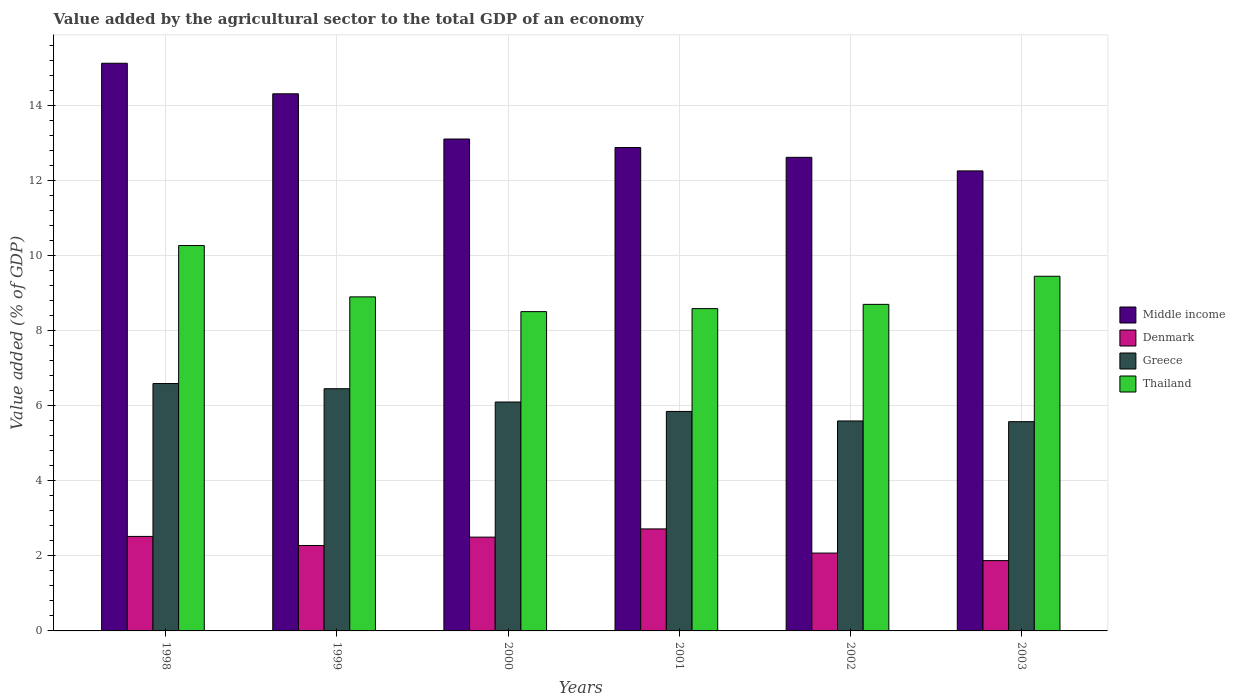How many different coloured bars are there?
Make the answer very short. 4. How many groups of bars are there?
Your answer should be very brief. 6. Are the number of bars per tick equal to the number of legend labels?
Ensure brevity in your answer.  Yes. Are the number of bars on each tick of the X-axis equal?
Offer a terse response. Yes. What is the label of the 4th group of bars from the left?
Give a very brief answer. 2001. In how many cases, is the number of bars for a given year not equal to the number of legend labels?
Provide a succinct answer. 0. What is the value added by the agricultural sector to the total GDP in Middle income in 2003?
Provide a succinct answer. 12.25. Across all years, what is the maximum value added by the agricultural sector to the total GDP in Thailand?
Ensure brevity in your answer.  10.26. Across all years, what is the minimum value added by the agricultural sector to the total GDP in Greece?
Provide a short and direct response. 5.57. What is the total value added by the agricultural sector to the total GDP in Middle income in the graph?
Your answer should be very brief. 80.26. What is the difference between the value added by the agricultural sector to the total GDP in Thailand in 1998 and that in 2002?
Keep it short and to the point. 1.57. What is the difference between the value added by the agricultural sector to the total GDP in Greece in 2000 and the value added by the agricultural sector to the total GDP in Denmark in 1998?
Give a very brief answer. 3.58. What is the average value added by the agricultural sector to the total GDP in Thailand per year?
Ensure brevity in your answer.  9.06. In the year 1998, what is the difference between the value added by the agricultural sector to the total GDP in Denmark and value added by the agricultural sector to the total GDP in Thailand?
Provide a short and direct response. -7.75. What is the ratio of the value added by the agricultural sector to the total GDP in Greece in 1998 to that in 2000?
Offer a very short reply. 1.08. Is the difference between the value added by the agricultural sector to the total GDP in Denmark in 1999 and 2000 greater than the difference between the value added by the agricultural sector to the total GDP in Thailand in 1999 and 2000?
Provide a succinct answer. No. What is the difference between the highest and the second highest value added by the agricultural sector to the total GDP in Denmark?
Provide a short and direct response. 0.2. What is the difference between the highest and the lowest value added by the agricultural sector to the total GDP in Middle income?
Provide a short and direct response. 2.87. What does the 4th bar from the left in 2002 represents?
Your answer should be very brief. Thailand. What does the 2nd bar from the right in 2003 represents?
Your answer should be very brief. Greece. Is it the case that in every year, the sum of the value added by the agricultural sector to the total GDP in Thailand and value added by the agricultural sector to the total GDP in Middle income is greater than the value added by the agricultural sector to the total GDP in Greece?
Keep it short and to the point. Yes. Are all the bars in the graph horizontal?
Your answer should be compact. No. What is the difference between two consecutive major ticks on the Y-axis?
Give a very brief answer. 2. Does the graph contain any zero values?
Your response must be concise. No. Does the graph contain grids?
Give a very brief answer. Yes. How many legend labels are there?
Your response must be concise. 4. What is the title of the graph?
Keep it short and to the point. Value added by the agricultural sector to the total GDP of an economy. Does "Panama" appear as one of the legend labels in the graph?
Your response must be concise. No. What is the label or title of the X-axis?
Your response must be concise. Years. What is the label or title of the Y-axis?
Offer a very short reply. Value added (% of GDP). What is the Value added (% of GDP) of Middle income in 1998?
Make the answer very short. 15.12. What is the Value added (% of GDP) in Denmark in 1998?
Your answer should be very brief. 2.52. What is the Value added (% of GDP) in Greece in 1998?
Offer a very short reply. 6.59. What is the Value added (% of GDP) of Thailand in 1998?
Offer a very short reply. 10.26. What is the Value added (% of GDP) in Middle income in 1999?
Give a very brief answer. 14.3. What is the Value added (% of GDP) of Denmark in 1999?
Give a very brief answer. 2.28. What is the Value added (% of GDP) of Greece in 1999?
Provide a short and direct response. 6.45. What is the Value added (% of GDP) in Thailand in 1999?
Provide a succinct answer. 8.9. What is the Value added (% of GDP) of Middle income in 2000?
Your answer should be compact. 13.1. What is the Value added (% of GDP) in Denmark in 2000?
Your answer should be very brief. 2.5. What is the Value added (% of GDP) in Greece in 2000?
Offer a very short reply. 6.1. What is the Value added (% of GDP) in Thailand in 2000?
Provide a short and direct response. 8.5. What is the Value added (% of GDP) of Middle income in 2001?
Ensure brevity in your answer.  12.87. What is the Value added (% of GDP) in Denmark in 2001?
Ensure brevity in your answer.  2.72. What is the Value added (% of GDP) in Greece in 2001?
Make the answer very short. 5.84. What is the Value added (% of GDP) of Thailand in 2001?
Provide a short and direct response. 8.58. What is the Value added (% of GDP) in Middle income in 2002?
Your response must be concise. 12.61. What is the Value added (% of GDP) of Denmark in 2002?
Give a very brief answer. 2.07. What is the Value added (% of GDP) of Greece in 2002?
Give a very brief answer. 5.59. What is the Value added (% of GDP) of Thailand in 2002?
Your response must be concise. 8.7. What is the Value added (% of GDP) in Middle income in 2003?
Your answer should be compact. 12.25. What is the Value added (% of GDP) of Denmark in 2003?
Provide a succinct answer. 1.87. What is the Value added (% of GDP) in Greece in 2003?
Offer a terse response. 5.57. What is the Value added (% of GDP) in Thailand in 2003?
Ensure brevity in your answer.  9.44. Across all years, what is the maximum Value added (% of GDP) in Middle income?
Offer a very short reply. 15.12. Across all years, what is the maximum Value added (% of GDP) of Denmark?
Your answer should be compact. 2.72. Across all years, what is the maximum Value added (% of GDP) in Greece?
Make the answer very short. 6.59. Across all years, what is the maximum Value added (% of GDP) of Thailand?
Keep it short and to the point. 10.26. Across all years, what is the minimum Value added (% of GDP) in Middle income?
Make the answer very short. 12.25. Across all years, what is the minimum Value added (% of GDP) of Denmark?
Your response must be concise. 1.87. Across all years, what is the minimum Value added (% of GDP) of Greece?
Offer a very short reply. 5.57. Across all years, what is the minimum Value added (% of GDP) in Thailand?
Give a very brief answer. 8.5. What is the total Value added (% of GDP) in Middle income in the graph?
Your response must be concise. 80.26. What is the total Value added (% of GDP) in Denmark in the graph?
Your answer should be compact. 13.95. What is the total Value added (% of GDP) in Greece in the graph?
Offer a terse response. 36.14. What is the total Value added (% of GDP) of Thailand in the graph?
Your answer should be very brief. 54.38. What is the difference between the Value added (% of GDP) in Middle income in 1998 and that in 1999?
Make the answer very short. 0.81. What is the difference between the Value added (% of GDP) of Denmark in 1998 and that in 1999?
Offer a terse response. 0.24. What is the difference between the Value added (% of GDP) of Greece in 1998 and that in 1999?
Give a very brief answer. 0.14. What is the difference between the Value added (% of GDP) in Thailand in 1998 and that in 1999?
Keep it short and to the point. 1.37. What is the difference between the Value added (% of GDP) in Middle income in 1998 and that in 2000?
Give a very brief answer. 2.02. What is the difference between the Value added (% of GDP) of Denmark in 1998 and that in 2000?
Provide a succinct answer. 0.02. What is the difference between the Value added (% of GDP) in Greece in 1998 and that in 2000?
Keep it short and to the point. 0.49. What is the difference between the Value added (% of GDP) in Thailand in 1998 and that in 2000?
Provide a short and direct response. 1.76. What is the difference between the Value added (% of GDP) in Middle income in 1998 and that in 2001?
Provide a short and direct response. 2.24. What is the difference between the Value added (% of GDP) in Denmark in 1998 and that in 2001?
Your answer should be very brief. -0.2. What is the difference between the Value added (% of GDP) of Greece in 1998 and that in 2001?
Provide a short and direct response. 0.74. What is the difference between the Value added (% of GDP) of Thailand in 1998 and that in 2001?
Ensure brevity in your answer.  1.68. What is the difference between the Value added (% of GDP) in Middle income in 1998 and that in 2002?
Your response must be concise. 2.51. What is the difference between the Value added (% of GDP) of Denmark in 1998 and that in 2002?
Ensure brevity in your answer.  0.44. What is the difference between the Value added (% of GDP) in Greece in 1998 and that in 2002?
Your response must be concise. 1. What is the difference between the Value added (% of GDP) in Thailand in 1998 and that in 2002?
Your answer should be very brief. 1.57. What is the difference between the Value added (% of GDP) in Middle income in 1998 and that in 2003?
Your answer should be very brief. 2.87. What is the difference between the Value added (% of GDP) of Denmark in 1998 and that in 2003?
Make the answer very short. 0.64. What is the difference between the Value added (% of GDP) in Thailand in 1998 and that in 2003?
Your answer should be compact. 0.82. What is the difference between the Value added (% of GDP) in Middle income in 1999 and that in 2000?
Give a very brief answer. 1.2. What is the difference between the Value added (% of GDP) in Denmark in 1999 and that in 2000?
Keep it short and to the point. -0.22. What is the difference between the Value added (% of GDP) of Greece in 1999 and that in 2000?
Make the answer very short. 0.35. What is the difference between the Value added (% of GDP) of Thailand in 1999 and that in 2000?
Give a very brief answer. 0.39. What is the difference between the Value added (% of GDP) in Middle income in 1999 and that in 2001?
Ensure brevity in your answer.  1.43. What is the difference between the Value added (% of GDP) of Denmark in 1999 and that in 2001?
Offer a terse response. -0.44. What is the difference between the Value added (% of GDP) of Greece in 1999 and that in 2001?
Your answer should be compact. 0.61. What is the difference between the Value added (% of GDP) of Thailand in 1999 and that in 2001?
Offer a terse response. 0.31. What is the difference between the Value added (% of GDP) in Middle income in 1999 and that in 2002?
Ensure brevity in your answer.  1.69. What is the difference between the Value added (% of GDP) in Denmark in 1999 and that in 2002?
Your answer should be very brief. 0.2. What is the difference between the Value added (% of GDP) of Greece in 1999 and that in 2002?
Ensure brevity in your answer.  0.86. What is the difference between the Value added (% of GDP) in Thailand in 1999 and that in 2002?
Offer a terse response. 0.2. What is the difference between the Value added (% of GDP) in Middle income in 1999 and that in 2003?
Your answer should be compact. 2.05. What is the difference between the Value added (% of GDP) in Denmark in 1999 and that in 2003?
Keep it short and to the point. 0.4. What is the difference between the Value added (% of GDP) in Greece in 1999 and that in 2003?
Your answer should be very brief. 0.88. What is the difference between the Value added (% of GDP) in Thailand in 1999 and that in 2003?
Your answer should be compact. -0.55. What is the difference between the Value added (% of GDP) in Middle income in 2000 and that in 2001?
Your answer should be compact. 0.23. What is the difference between the Value added (% of GDP) of Denmark in 2000 and that in 2001?
Your answer should be very brief. -0.22. What is the difference between the Value added (% of GDP) of Greece in 2000 and that in 2001?
Your answer should be very brief. 0.25. What is the difference between the Value added (% of GDP) of Thailand in 2000 and that in 2001?
Keep it short and to the point. -0.08. What is the difference between the Value added (% of GDP) in Middle income in 2000 and that in 2002?
Ensure brevity in your answer.  0.49. What is the difference between the Value added (% of GDP) in Denmark in 2000 and that in 2002?
Ensure brevity in your answer.  0.42. What is the difference between the Value added (% of GDP) of Greece in 2000 and that in 2002?
Offer a very short reply. 0.5. What is the difference between the Value added (% of GDP) of Thailand in 2000 and that in 2002?
Provide a short and direct response. -0.19. What is the difference between the Value added (% of GDP) in Middle income in 2000 and that in 2003?
Your response must be concise. 0.85. What is the difference between the Value added (% of GDP) of Denmark in 2000 and that in 2003?
Offer a terse response. 0.63. What is the difference between the Value added (% of GDP) of Greece in 2000 and that in 2003?
Ensure brevity in your answer.  0.52. What is the difference between the Value added (% of GDP) of Thailand in 2000 and that in 2003?
Ensure brevity in your answer.  -0.94. What is the difference between the Value added (% of GDP) of Middle income in 2001 and that in 2002?
Your response must be concise. 0.26. What is the difference between the Value added (% of GDP) in Denmark in 2001 and that in 2002?
Your response must be concise. 0.64. What is the difference between the Value added (% of GDP) of Greece in 2001 and that in 2002?
Provide a short and direct response. 0.25. What is the difference between the Value added (% of GDP) in Thailand in 2001 and that in 2002?
Your answer should be compact. -0.11. What is the difference between the Value added (% of GDP) in Middle income in 2001 and that in 2003?
Your response must be concise. 0.62. What is the difference between the Value added (% of GDP) in Denmark in 2001 and that in 2003?
Provide a succinct answer. 0.84. What is the difference between the Value added (% of GDP) in Greece in 2001 and that in 2003?
Your answer should be very brief. 0.27. What is the difference between the Value added (% of GDP) of Thailand in 2001 and that in 2003?
Offer a very short reply. -0.86. What is the difference between the Value added (% of GDP) in Middle income in 2002 and that in 2003?
Provide a succinct answer. 0.36. What is the difference between the Value added (% of GDP) of Denmark in 2002 and that in 2003?
Keep it short and to the point. 0.2. What is the difference between the Value added (% of GDP) in Greece in 2002 and that in 2003?
Provide a succinct answer. 0.02. What is the difference between the Value added (% of GDP) in Thailand in 2002 and that in 2003?
Offer a terse response. -0.75. What is the difference between the Value added (% of GDP) in Middle income in 1998 and the Value added (% of GDP) in Denmark in 1999?
Give a very brief answer. 12.84. What is the difference between the Value added (% of GDP) in Middle income in 1998 and the Value added (% of GDP) in Greece in 1999?
Make the answer very short. 8.67. What is the difference between the Value added (% of GDP) in Middle income in 1998 and the Value added (% of GDP) in Thailand in 1999?
Offer a terse response. 6.22. What is the difference between the Value added (% of GDP) of Denmark in 1998 and the Value added (% of GDP) of Greece in 1999?
Your response must be concise. -3.93. What is the difference between the Value added (% of GDP) of Denmark in 1998 and the Value added (% of GDP) of Thailand in 1999?
Keep it short and to the point. -6.38. What is the difference between the Value added (% of GDP) in Greece in 1998 and the Value added (% of GDP) in Thailand in 1999?
Your answer should be very brief. -2.31. What is the difference between the Value added (% of GDP) in Middle income in 1998 and the Value added (% of GDP) in Denmark in 2000?
Ensure brevity in your answer.  12.62. What is the difference between the Value added (% of GDP) in Middle income in 1998 and the Value added (% of GDP) in Greece in 2000?
Keep it short and to the point. 9.02. What is the difference between the Value added (% of GDP) of Middle income in 1998 and the Value added (% of GDP) of Thailand in 2000?
Offer a terse response. 6.61. What is the difference between the Value added (% of GDP) of Denmark in 1998 and the Value added (% of GDP) of Greece in 2000?
Make the answer very short. -3.58. What is the difference between the Value added (% of GDP) in Denmark in 1998 and the Value added (% of GDP) in Thailand in 2000?
Offer a terse response. -5.99. What is the difference between the Value added (% of GDP) of Greece in 1998 and the Value added (% of GDP) of Thailand in 2000?
Keep it short and to the point. -1.92. What is the difference between the Value added (% of GDP) in Middle income in 1998 and the Value added (% of GDP) in Denmark in 2001?
Offer a terse response. 12.4. What is the difference between the Value added (% of GDP) of Middle income in 1998 and the Value added (% of GDP) of Greece in 2001?
Give a very brief answer. 9.27. What is the difference between the Value added (% of GDP) in Middle income in 1998 and the Value added (% of GDP) in Thailand in 2001?
Keep it short and to the point. 6.53. What is the difference between the Value added (% of GDP) in Denmark in 1998 and the Value added (% of GDP) in Greece in 2001?
Make the answer very short. -3.33. What is the difference between the Value added (% of GDP) in Denmark in 1998 and the Value added (% of GDP) in Thailand in 2001?
Your answer should be compact. -6.07. What is the difference between the Value added (% of GDP) in Greece in 1998 and the Value added (% of GDP) in Thailand in 2001?
Keep it short and to the point. -1.99. What is the difference between the Value added (% of GDP) in Middle income in 1998 and the Value added (% of GDP) in Denmark in 2002?
Your answer should be very brief. 13.04. What is the difference between the Value added (% of GDP) of Middle income in 1998 and the Value added (% of GDP) of Greece in 2002?
Make the answer very short. 9.53. What is the difference between the Value added (% of GDP) in Middle income in 1998 and the Value added (% of GDP) in Thailand in 2002?
Provide a succinct answer. 6.42. What is the difference between the Value added (% of GDP) in Denmark in 1998 and the Value added (% of GDP) in Greece in 2002?
Give a very brief answer. -3.07. What is the difference between the Value added (% of GDP) in Denmark in 1998 and the Value added (% of GDP) in Thailand in 2002?
Make the answer very short. -6.18. What is the difference between the Value added (% of GDP) of Greece in 1998 and the Value added (% of GDP) of Thailand in 2002?
Keep it short and to the point. -2.11. What is the difference between the Value added (% of GDP) of Middle income in 1998 and the Value added (% of GDP) of Denmark in 2003?
Offer a very short reply. 13.24. What is the difference between the Value added (% of GDP) of Middle income in 1998 and the Value added (% of GDP) of Greece in 2003?
Your answer should be compact. 9.54. What is the difference between the Value added (% of GDP) of Middle income in 1998 and the Value added (% of GDP) of Thailand in 2003?
Provide a succinct answer. 5.67. What is the difference between the Value added (% of GDP) in Denmark in 1998 and the Value added (% of GDP) in Greece in 2003?
Your answer should be compact. -3.06. What is the difference between the Value added (% of GDP) of Denmark in 1998 and the Value added (% of GDP) of Thailand in 2003?
Give a very brief answer. -6.93. What is the difference between the Value added (% of GDP) in Greece in 1998 and the Value added (% of GDP) in Thailand in 2003?
Give a very brief answer. -2.86. What is the difference between the Value added (% of GDP) of Middle income in 1999 and the Value added (% of GDP) of Denmark in 2000?
Offer a terse response. 11.81. What is the difference between the Value added (% of GDP) in Middle income in 1999 and the Value added (% of GDP) in Greece in 2000?
Keep it short and to the point. 8.21. What is the difference between the Value added (% of GDP) of Middle income in 1999 and the Value added (% of GDP) of Thailand in 2000?
Your answer should be very brief. 5.8. What is the difference between the Value added (% of GDP) of Denmark in 1999 and the Value added (% of GDP) of Greece in 2000?
Provide a short and direct response. -3.82. What is the difference between the Value added (% of GDP) of Denmark in 1999 and the Value added (% of GDP) of Thailand in 2000?
Provide a succinct answer. -6.23. What is the difference between the Value added (% of GDP) of Greece in 1999 and the Value added (% of GDP) of Thailand in 2000?
Provide a short and direct response. -2.05. What is the difference between the Value added (% of GDP) in Middle income in 1999 and the Value added (% of GDP) in Denmark in 2001?
Provide a succinct answer. 11.59. What is the difference between the Value added (% of GDP) of Middle income in 1999 and the Value added (% of GDP) of Greece in 2001?
Your answer should be compact. 8.46. What is the difference between the Value added (% of GDP) of Middle income in 1999 and the Value added (% of GDP) of Thailand in 2001?
Offer a terse response. 5.72. What is the difference between the Value added (% of GDP) in Denmark in 1999 and the Value added (% of GDP) in Greece in 2001?
Your answer should be very brief. -3.57. What is the difference between the Value added (% of GDP) of Denmark in 1999 and the Value added (% of GDP) of Thailand in 2001?
Your answer should be very brief. -6.31. What is the difference between the Value added (% of GDP) of Greece in 1999 and the Value added (% of GDP) of Thailand in 2001?
Keep it short and to the point. -2.13. What is the difference between the Value added (% of GDP) of Middle income in 1999 and the Value added (% of GDP) of Denmark in 2002?
Your response must be concise. 12.23. What is the difference between the Value added (% of GDP) in Middle income in 1999 and the Value added (% of GDP) in Greece in 2002?
Offer a terse response. 8.71. What is the difference between the Value added (% of GDP) in Middle income in 1999 and the Value added (% of GDP) in Thailand in 2002?
Offer a very short reply. 5.61. What is the difference between the Value added (% of GDP) in Denmark in 1999 and the Value added (% of GDP) in Greece in 2002?
Your answer should be very brief. -3.32. What is the difference between the Value added (% of GDP) of Denmark in 1999 and the Value added (% of GDP) of Thailand in 2002?
Offer a terse response. -6.42. What is the difference between the Value added (% of GDP) of Greece in 1999 and the Value added (% of GDP) of Thailand in 2002?
Offer a terse response. -2.25. What is the difference between the Value added (% of GDP) in Middle income in 1999 and the Value added (% of GDP) in Denmark in 2003?
Give a very brief answer. 12.43. What is the difference between the Value added (% of GDP) of Middle income in 1999 and the Value added (% of GDP) of Greece in 2003?
Provide a short and direct response. 8.73. What is the difference between the Value added (% of GDP) in Middle income in 1999 and the Value added (% of GDP) in Thailand in 2003?
Your response must be concise. 4.86. What is the difference between the Value added (% of GDP) of Denmark in 1999 and the Value added (% of GDP) of Greece in 2003?
Provide a succinct answer. -3.3. What is the difference between the Value added (% of GDP) of Denmark in 1999 and the Value added (% of GDP) of Thailand in 2003?
Offer a very short reply. -7.17. What is the difference between the Value added (% of GDP) in Greece in 1999 and the Value added (% of GDP) in Thailand in 2003?
Your response must be concise. -2.99. What is the difference between the Value added (% of GDP) in Middle income in 2000 and the Value added (% of GDP) in Denmark in 2001?
Make the answer very short. 10.38. What is the difference between the Value added (% of GDP) in Middle income in 2000 and the Value added (% of GDP) in Greece in 2001?
Provide a short and direct response. 7.25. What is the difference between the Value added (% of GDP) in Middle income in 2000 and the Value added (% of GDP) in Thailand in 2001?
Your response must be concise. 4.52. What is the difference between the Value added (% of GDP) in Denmark in 2000 and the Value added (% of GDP) in Greece in 2001?
Your response must be concise. -3.35. What is the difference between the Value added (% of GDP) of Denmark in 2000 and the Value added (% of GDP) of Thailand in 2001?
Your response must be concise. -6.08. What is the difference between the Value added (% of GDP) in Greece in 2000 and the Value added (% of GDP) in Thailand in 2001?
Ensure brevity in your answer.  -2.49. What is the difference between the Value added (% of GDP) in Middle income in 2000 and the Value added (% of GDP) in Denmark in 2002?
Offer a terse response. 11.03. What is the difference between the Value added (% of GDP) of Middle income in 2000 and the Value added (% of GDP) of Greece in 2002?
Keep it short and to the point. 7.51. What is the difference between the Value added (% of GDP) in Middle income in 2000 and the Value added (% of GDP) in Thailand in 2002?
Provide a short and direct response. 4.4. What is the difference between the Value added (% of GDP) in Denmark in 2000 and the Value added (% of GDP) in Greece in 2002?
Ensure brevity in your answer.  -3.09. What is the difference between the Value added (% of GDP) in Denmark in 2000 and the Value added (% of GDP) in Thailand in 2002?
Provide a short and direct response. -6.2. What is the difference between the Value added (% of GDP) in Greece in 2000 and the Value added (% of GDP) in Thailand in 2002?
Ensure brevity in your answer.  -2.6. What is the difference between the Value added (% of GDP) in Middle income in 2000 and the Value added (% of GDP) in Denmark in 2003?
Ensure brevity in your answer.  11.23. What is the difference between the Value added (% of GDP) of Middle income in 2000 and the Value added (% of GDP) of Greece in 2003?
Your answer should be very brief. 7.53. What is the difference between the Value added (% of GDP) of Middle income in 2000 and the Value added (% of GDP) of Thailand in 2003?
Ensure brevity in your answer.  3.65. What is the difference between the Value added (% of GDP) of Denmark in 2000 and the Value added (% of GDP) of Greece in 2003?
Your answer should be very brief. -3.07. What is the difference between the Value added (% of GDP) in Denmark in 2000 and the Value added (% of GDP) in Thailand in 2003?
Keep it short and to the point. -6.95. What is the difference between the Value added (% of GDP) of Greece in 2000 and the Value added (% of GDP) of Thailand in 2003?
Make the answer very short. -3.35. What is the difference between the Value added (% of GDP) of Middle income in 2001 and the Value added (% of GDP) of Denmark in 2002?
Make the answer very short. 10.8. What is the difference between the Value added (% of GDP) of Middle income in 2001 and the Value added (% of GDP) of Greece in 2002?
Offer a very short reply. 7.28. What is the difference between the Value added (% of GDP) in Middle income in 2001 and the Value added (% of GDP) in Thailand in 2002?
Keep it short and to the point. 4.18. What is the difference between the Value added (% of GDP) of Denmark in 2001 and the Value added (% of GDP) of Greece in 2002?
Give a very brief answer. -2.87. What is the difference between the Value added (% of GDP) in Denmark in 2001 and the Value added (% of GDP) in Thailand in 2002?
Your answer should be very brief. -5.98. What is the difference between the Value added (% of GDP) in Greece in 2001 and the Value added (% of GDP) in Thailand in 2002?
Give a very brief answer. -2.85. What is the difference between the Value added (% of GDP) of Middle income in 2001 and the Value added (% of GDP) of Denmark in 2003?
Offer a very short reply. 11. What is the difference between the Value added (% of GDP) in Middle income in 2001 and the Value added (% of GDP) in Greece in 2003?
Give a very brief answer. 7.3. What is the difference between the Value added (% of GDP) of Middle income in 2001 and the Value added (% of GDP) of Thailand in 2003?
Offer a terse response. 3.43. What is the difference between the Value added (% of GDP) of Denmark in 2001 and the Value added (% of GDP) of Greece in 2003?
Provide a short and direct response. -2.86. What is the difference between the Value added (% of GDP) in Denmark in 2001 and the Value added (% of GDP) in Thailand in 2003?
Give a very brief answer. -6.73. What is the difference between the Value added (% of GDP) in Greece in 2001 and the Value added (% of GDP) in Thailand in 2003?
Your response must be concise. -3.6. What is the difference between the Value added (% of GDP) in Middle income in 2002 and the Value added (% of GDP) in Denmark in 2003?
Provide a short and direct response. 10.74. What is the difference between the Value added (% of GDP) in Middle income in 2002 and the Value added (% of GDP) in Greece in 2003?
Give a very brief answer. 7.04. What is the difference between the Value added (% of GDP) in Middle income in 2002 and the Value added (% of GDP) in Thailand in 2003?
Keep it short and to the point. 3.17. What is the difference between the Value added (% of GDP) in Denmark in 2002 and the Value added (% of GDP) in Greece in 2003?
Your response must be concise. -3.5. What is the difference between the Value added (% of GDP) of Denmark in 2002 and the Value added (% of GDP) of Thailand in 2003?
Provide a short and direct response. -7.37. What is the difference between the Value added (% of GDP) in Greece in 2002 and the Value added (% of GDP) in Thailand in 2003?
Your answer should be very brief. -3.85. What is the average Value added (% of GDP) of Middle income per year?
Provide a succinct answer. 13.38. What is the average Value added (% of GDP) of Denmark per year?
Give a very brief answer. 2.33. What is the average Value added (% of GDP) of Greece per year?
Provide a short and direct response. 6.02. What is the average Value added (% of GDP) in Thailand per year?
Provide a short and direct response. 9.06. In the year 1998, what is the difference between the Value added (% of GDP) in Middle income and Value added (% of GDP) in Denmark?
Offer a very short reply. 12.6. In the year 1998, what is the difference between the Value added (% of GDP) of Middle income and Value added (% of GDP) of Greece?
Keep it short and to the point. 8.53. In the year 1998, what is the difference between the Value added (% of GDP) of Middle income and Value added (% of GDP) of Thailand?
Your answer should be very brief. 4.85. In the year 1998, what is the difference between the Value added (% of GDP) of Denmark and Value added (% of GDP) of Greece?
Keep it short and to the point. -4.07. In the year 1998, what is the difference between the Value added (% of GDP) of Denmark and Value added (% of GDP) of Thailand?
Keep it short and to the point. -7.75. In the year 1998, what is the difference between the Value added (% of GDP) in Greece and Value added (% of GDP) in Thailand?
Keep it short and to the point. -3.67. In the year 1999, what is the difference between the Value added (% of GDP) of Middle income and Value added (% of GDP) of Denmark?
Offer a terse response. 12.03. In the year 1999, what is the difference between the Value added (% of GDP) in Middle income and Value added (% of GDP) in Greece?
Your answer should be compact. 7.85. In the year 1999, what is the difference between the Value added (% of GDP) of Middle income and Value added (% of GDP) of Thailand?
Give a very brief answer. 5.41. In the year 1999, what is the difference between the Value added (% of GDP) in Denmark and Value added (% of GDP) in Greece?
Keep it short and to the point. -4.18. In the year 1999, what is the difference between the Value added (% of GDP) in Denmark and Value added (% of GDP) in Thailand?
Make the answer very short. -6.62. In the year 1999, what is the difference between the Value added (% of GDP) in Greece and Value added (% of GDP) in Thailand?
Your answer should be compact. -2.45. In the year 2000, what is the difference between the Value added (% of GDP) in Middle income and Value added (% of GDP) in Denmark?
Provide a succinct answer. 10.6. In the year 2000, what is the difference between the Value added (% of GDP) of Middle income and Value added (% of GDP) of Greece?
Offer a very short reply. 7. In the year 2000, what is the difference between the Value added (% of GDP) of Middle income and Value added (% of GDP) of Thailand?
Ensure brevity in your answer.  4.6. In the year 2000, what is the difference between the Value added (% of GDP) in Denmark and Value added (% of GDP) in Greece?
Ensure brevity in your answer.  -3.6. In the year 2000, what is the difference between the Value added (% of GDP) in Denmark and Value added (% of GDP) in Thailand?
Your answer should be compact. -6.01. In the year 2000, what is the difference between the Value added (% of GDP) in Greece and Value added (% of GDP) in Thailand?
Provide a succinct answer. -2.41. In the year 2001, what is the difference between the Value added (% of GDP) of Middle income and Value added (% of GDP) of Denmark?
Make the answer very short. 10.16. In the year 2001, what is the difference between the Value added (% of GDP) in Middle income and Value added (% of GDP) in Greece?
Ensure brevity in your answer.  7.03. In the year 2001, what is the difference between the Value added (% of GDP) of Middle income and Value added (% of GDP) of Thailand?
Offer a terse response. 4.29. In the year 2001, what is the difference between the Value added (% of GDP) in Denmark and Value added (% of GDP) in Greece?
Provide a short and direct response. -3.13. In the year 2001, what is the difference between the Value added (% of GDP) of Denmark and Value added (% of GDP) of Thailand?
Your response must be concise. -5.87. In the year 2001, what is the difference between the Value added (% of GDP) of Greece and Value added (% of GDP) of Thailand?
Give a very brief answer. -2.74. In the year 2002, what is the difference between the Value added (% of GDP) of Middle income and Value added (% of GDP) of Denmark?
Give a very brief answer. 10.54. In the year 2002, what is the difference between the Value added (% of GDP) in Middle income and Value added (% of GDP) in Greece?
Provide a succinct answer. 7.02. In the year 2002, what is the difference between the Value added (% of GDP) in Middle income and Value added (% of GDP) in Thailand?
Offer a terse response. 3.92. In the year 2002, what is the difference between the Value added (% of GDP) in Denmark and Value added (% of GDP) in Greece?
Your answer should be compact. -3.52. In the year 2002, what is the difference between the Value added (% of GDP) in Denmark and Value added (% of GDP) in Thailand?
Keep it short and to the point. -6.62. In the year 2002, what is the difference between the Value added (% of GDP) in Greece and Value added (% of GDP) in Thailand?
Your answer should be compact. -3.1. In the year 2003, what is the difference between the Value added (% of GDP) in Middle income and Value added (% of GDP) in Denmark?
Your response must be concise. 10.38. In the year 2003, what is the difference between the Value added (% of GDP) in Middle income and Value added (% of GDP) in Greece?
Offer a terse response. 6.68. In the year 2003, what is the difference between the Value added (% of GDP) in Middle income and Value added (% of GDP) in Thailand?
Make the answer very short. 2.81. In the year 2003, what is the difference between the Value added (% of GDP) of Denmark and Value added (% of GDP) of Greece?
Make the answer very short. -3.7. In the year 2003, what is the difference between the Value added (% of GDP) in Denmark and Value added (% of GDP) in Thailand?
Your answer should be very brief. -7.57. In the year 2003, what is the difference between the Value added (% of GDP) in Greece and Value added (% of GDP) in Thailand?
Your answer should be compact. -3.87. What is the ratio of the Value added (% of GDP) in Middle income in 1998 to that in 1999?
Provide a short and direct response. 1.06. What is the ratio of the Value added (% of GDP) of Denmark in 1998 to that in 1999?
Your response must be concise. 1.11. What is the ratio of the Value added (% of GDP) in Greece in 1998 to that in 1999?
Make the answer very short. 1.02. What is the ratio of the Value added (% of GDP) in Thailand in 1998 to that in 1999?
Make the answer very short. 1.15. What is the ratio of the Value added (% of GDP) of Middle income in 1998 to that in 2000?
Offer a terse response. 1.15. What is the ratio of the Value added (% of GDP) of Denmark in 1998 to that in 2000?
Ensure brevity in your answer.  1.01. What is the ratio of the Value added (% of GDP) in Greece in 1998 to that in 2000?
Your answer should be very brief. 1.08. What is the ratio of the Value added (% of GDP) in Thailand in 1998 to that in 2000?
Your answer should be compact. 1.21. What is the ratio of the Value added (% of GDP) of Middle income in 1998 to that in 2001?
Your answer should be compact. 1.17. What is the ratio of the Value added (% of GDP) of Denmark in 1998 to that in 2001?
Make the answer very short. 0.93. What is the ratio of the Value added (% of GDP) in Greece in 1998 to that in 2001?
Offer a terse response. 1.13. What is the ratio of the Value added (% of GDP) of Thailand in 1998 to that in 2001?
Make the answer very short. 1.2. What is the ratio of the Value added (% of GDP) in Middle income in 1998 to that in 2002?
Offer a very short reply. 1.2. What is the ratio of the Value added (% of GDP) of Denmark in 1998 to that in 2002?
Give a very brief answer. 1.21. What is the ratio of the Value added (% of GDP) of Greece in 1998 to that in 2002?
Offer a terse response. 1.18. What is the ratio of the Value added (% of GDP) of Thailand in 1998 to that in 2002?
Offer a very short reply. 1.18. What is the ratio of the Value added (% of GDP) in Middle income in 1998 to that in 2003?
Your answer should be compact. 1.23. What is the ratio of the Value added (% of GDP) in Denmark in 1998 to that in 2003?
Make the answer very short. 1.34. What is the ratio of the Value added (% of GDP) of Greece in 1998 to that in 2003?
Offer a terse response. 1.18. What is the ratio of the Value added (% of GDP) in Thailand in 1998 to that in 2003?
Offer a very short reply. 1.09. What is the ratio of the Value added (% of GDP) in Middle income in 1999 to that in 2000?
Offer a very short reply. 1.09. What is the ratio of the Value added (% of GDP) of Denmark in 1999 to that in 2000?
Your answer should be compact. 0.91. What is the ratio of the Value added (% of GDP) in Greece in 1999 to that in 2000?
Offer a very short reply. 1.06. What is the ratio of the Value added (% of GDP) of Thailand in 1999 to that in 2000?
Your answer should be very brief. 1.05. What is the ratio of the Value added (% of GDP) in Middle income in 1999 to that in 2001?
Your answer should be very brief. 1.11. What is the ratio of the Value added (% of GDP) of Denmark in 1999 to that in 2001?
Keep it short and to the point. 0.84. What is the ratio of the Value added (% of GDP) of Greece in 1999 to that in 2001?
Your answer should be very brief. 1.1. What is the ratio of the Value added (% of GDP) of Thailand in 1999 to that in 2001?
Ensure brevity in your answer.  1.04. What is the ratio of the Value added (% of GDP) in Middle income in 1999 to that in 2002?
Keep it short and to the point. 1.13. What is the ratio of the Value added (% of GDP) in Denmark in 1999 to that in 2002?
Offer a very short reply. 1.1. What is the ratio of the Value added (% of GDP) of Greece in 1999 to that in 2002?
Ensure brevity in your answer.  1.15. What is the ratio of the Value added (% of GDP) in Middle income in 1999 to that in 2003?
Offer a terse response. 1.17. What is the ratio of the Value added (% of GDP) in Denmark in 1999 to that in 2003?
Ensure brevity in your answer.  1.21. What is the ratio of the Value added (% of GDP) of Greece in 1999 to that in 2003?
Make the answer very short. 1.16. What is the ratio of the Value added (% of GDP) in Thailand in 1999 to that in 2003?
Give a very brief answer. 0.94. What is the ratio of the Value added (% of GDP) in Middle income in 2000 to that in 2001?
Your answer should be compact. 1.02. What is the ratio of the Value added (% of GDP) of Denmark in 2000 to that in 2001?
Give a very brief answer. 0.92. What is the ratio of the Value added (% of GDP) in Greece in 2000 to that in 2001?
Provide a short and direct response. 1.04. What is the ratio of the Value added (% of GDP) in Thailand in 2000 to that in 2001?
Keep it short and to the point. 0.99. What is the ratio of the Value added (% of GDP) in Middle income in 2000 to that in 2002?
Provide a succinct answer. 1.04. What is the ratio of the Value added (% of GDP) in Denmark in 2000 to that in 2002?
Give a very brief answer. 1.2. What is the ratio of the Value added (% of GDP) in Greece in 2000 to that in 2002?
Make the answer very short. 1.09. What is the ratio of the Value added (% of GDP) of Thailand in 2000 to that in 2002?
Your answer should be very brief. 0.98. What is the ratio of the Value added (% of GDP) in Middle income in 2000 to that in 2003?
Offer a very short reply. 1.07. What is the ratio of the Value added (% of GDP) in Denmark in 2000 to that in 2003?
Provide a short and direct response. 1.33. What is the ratio of the Value added (% of GDP) in Greece in 2000 to that in 2003?
Your answer should be compact. 1.09. What is the ratio of the Value added (% of GDP) of Thailand in 2000 to that in 2003?
Keep it short and to the point. 0.9. What is the ratio of the Value added (% of GDP) in Middle income in 2001 to that in 2002?
Offer a terse response. 1.02. What is the ratio of the Value added (% of GDP) in Denmark in 2001 to that in 2002?
Provide a succinct answer. 1.31. What is the ratio of the Value added (% of GDP) of Greece in 2001 to that in 2002?
Keep it short and to the point. 1.05. What is the ratio of the Value added (% of GDP) in Thailand in 2001 to that in 2002?
Offer a terse response. 0.99. What is the ratio of the Value added (% of GDP) of Middle income in 2001 to that in 2003?
Give a very brief answer. 1.05. What is the ratio of the Value added (% of GDP) of Denmark in 2001 to that in 2003?
Make the answer very short. 1.45. What is the ratio of the Value added (% of GDP) in Greece in 2001 to that in 2003?
Offer a terse response. 1.05. What is the ratio of the Value added (% of GDP) of Thailand in 2001 to that in 2003?
Your answer should be very brief. 0.91. What is the ratio of the Value added (% of GDP) of Middle income in 2002 to that in 2003?
Your response must be concise. 1.03. What is the ratio of the Value added (% of GDP) of Denmark in 2002 to that in 2003?
Provide a short and direct response. 1.11. What is the ratio of the Value added (% of GDP) of Greece in 2002 to that in 2003?
Make the answer very short. 1. What is the ratio of the Value added (% of GDP) of Thailand in 2002 to that in 2003?
Offer a very short reply. 0.92. What is the difference between the highest and the second highest Value added (% of GDP) of Middle income?
Give a very brief answer. 0.81. What is the difference between the highest and the second highest Value added (% of GDP) in Denmark?
Provide a short and direct response. 0.2. What is the difference between the highest and the second highest Value added (% of GDP) of Greece?
Offer a terse response. 0.14. What is the difference between the highest and the second highest Value added (% of GDP) of Thailand?
Your response must be concise. 0.82. What is the difference between the highest and the lowest Value added (% of GDP) of Middle income?
Keep it short and to the point. 2.87. What is the difference between the highest and the lowest Value added (% of GDP) in Denmark?
Give a very brief answer. 0.84. What is the difference between the highest and the lowest Value added (% of GDP) of Thailand?
Your answer should be very brief. 1.76. 